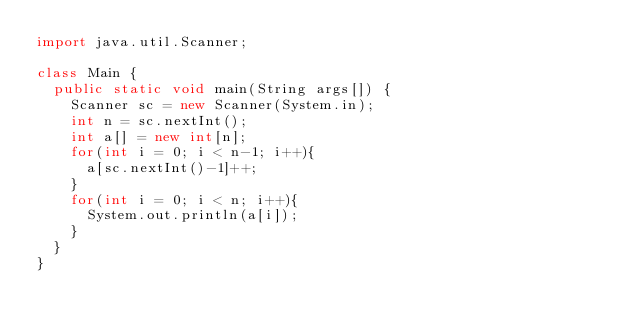<code> <loc_0><loc_0><loc_500><loc_500><_Java_>import java.util.Scanner;

class Main {
  public static void main(String args[]) {
    Scanner sc = new Scanner(System.in);
    int n = sc.nextInt();
    int a[] = new int[n];
    for(int i = 0; i < n-1; i++){
      a[sc.nextInt()-1]++;
    }
    for(int i = 0; i < n; i++){
      System.out.println(a[i]);
    }
  }
}</code> 